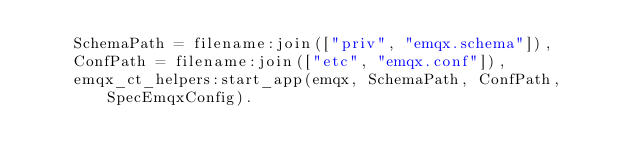Convert code to text. <code><loc_0><loc_0><loc_500><loc_500><_Erlang_>    SchemaPath = filename:join(["priv", "emqx.schema"]),
    ConfPath = filename:join(["etc", "emqx.conf"]),
    emqx_ct_helpers:start_app(emqx, SchemaPath, ConfPath, SpecEmqxConfig).
</code> 